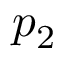Convert formula to latex. <formula><loc_0><loc_0><loc_500><loc_500>p _ { 2 }</formula> 